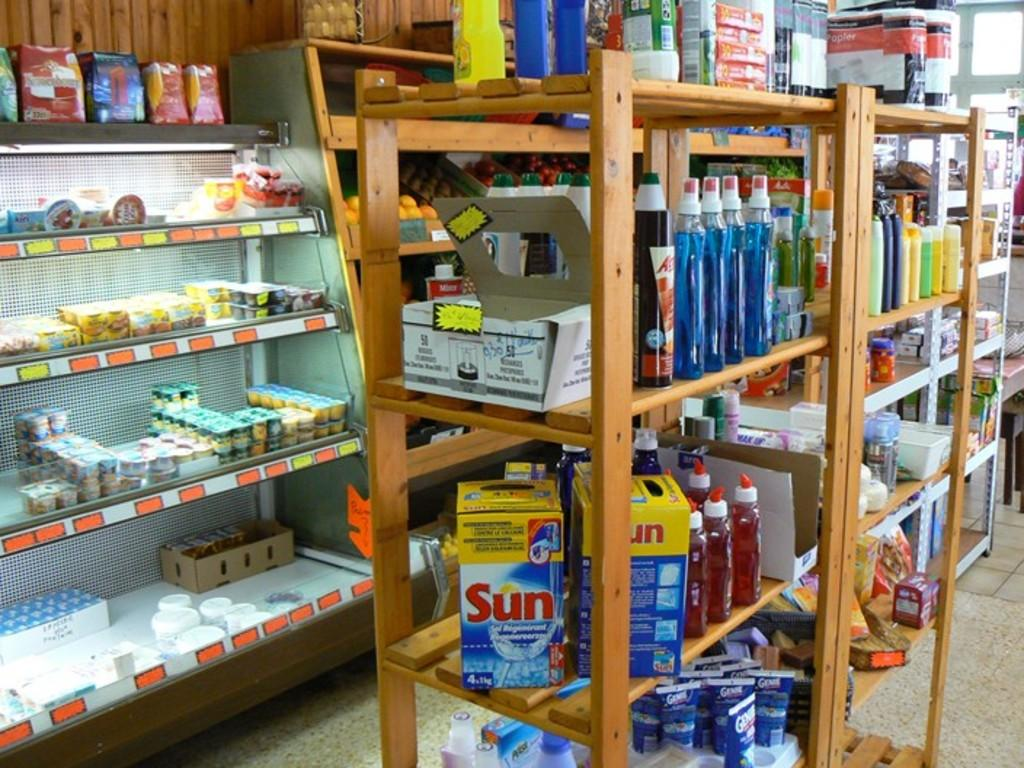<image>
Give a short and clear explanation of the subsequent image. Sun brand dishwashing liquid is for sale in a small market. 